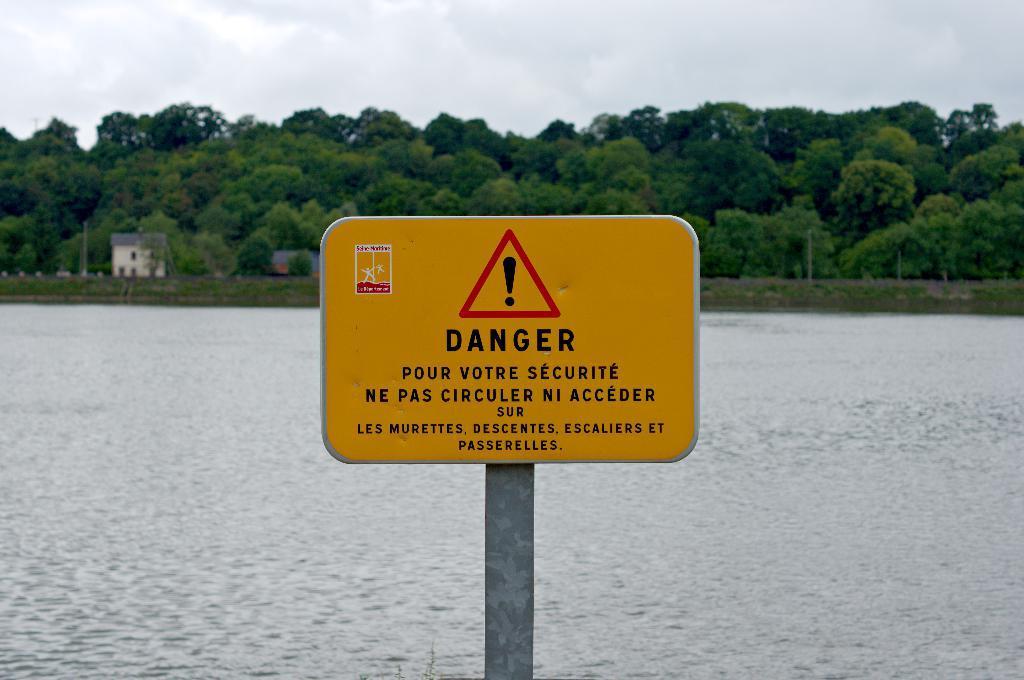Could you give a brief overview of what you see in this image? In this picture there is a board on the pole and there is a text on the board. At the back there are trees and there are buildings and there are poles. At the top there are clouds. At the bottom there is water. 